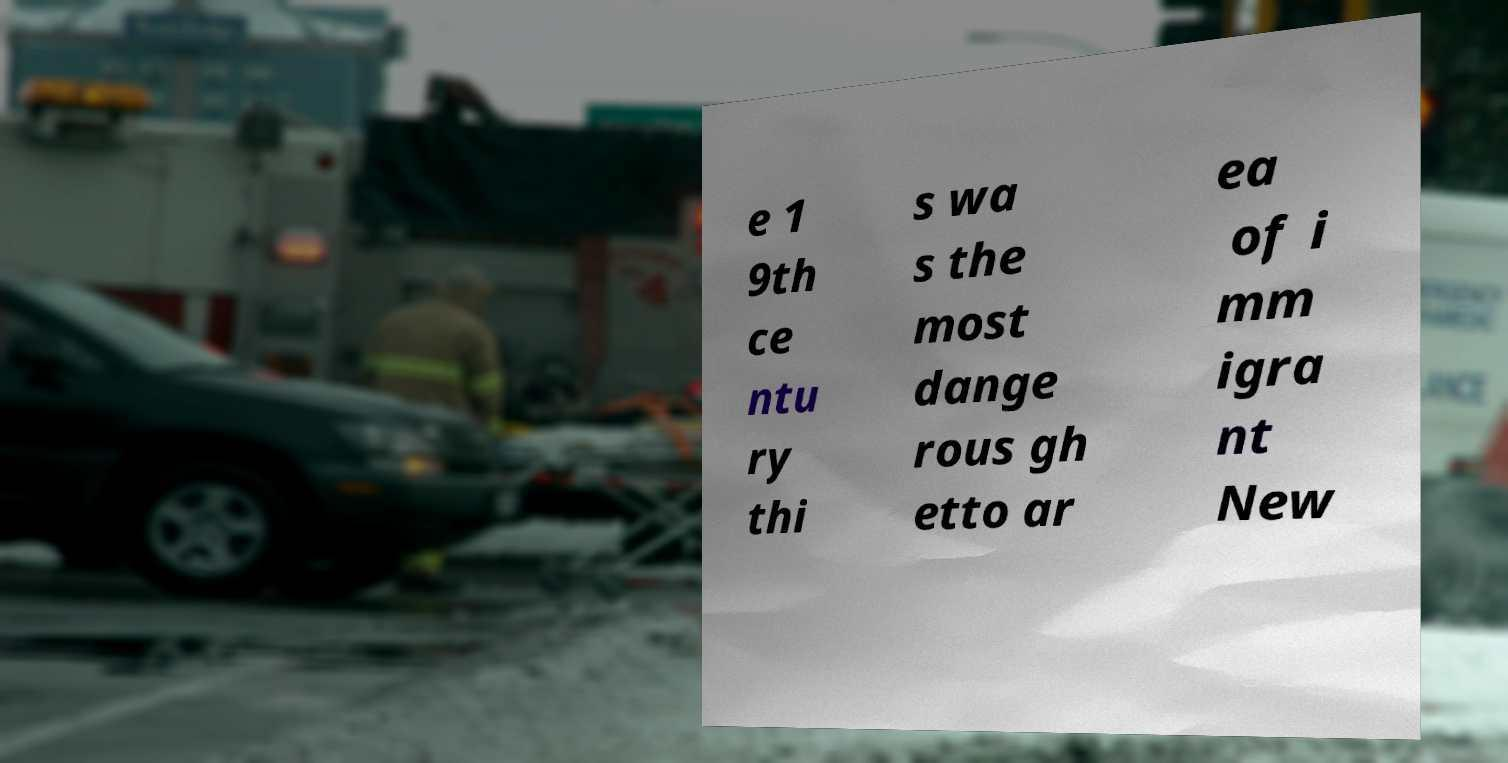Could you extract and type out the text from this image? e 1 9th ce ntu ry thi s wa s the most dange rous gh etto ar ea of i mm igra nt New 